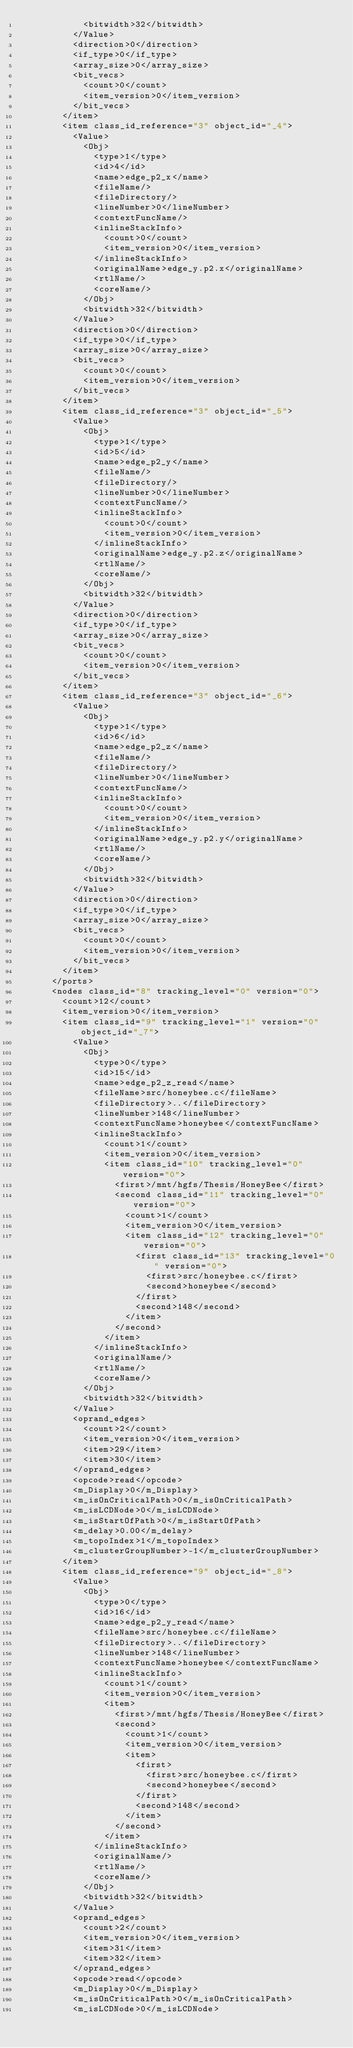Convert code to text. <code><loc_0><loc_0><loc_500><loc_500><_Ada_>            <bitwidth>32</bitwidth>
          </Value>
          <direction>0</direction>
          <if_type>0</if_type>
          <array_size>0</array_size>
          <bit_vecs>
            <count>0</count>
            <item_version>0</item_version>
          </bit_vecs>
        </item>
        <item class_id_reference="3" object_id="_4">
          <Value>
            <Obj>
              <type>1</type>
              <id>4</id>
              <name>edge_p2_x</name>
              <fileName/>
              <fileDirectory/>
              <lineNumber>0</lineNumber>
              <contextFuncName/>
              <inlineStackInfo>
                <count>0</count>
                <item_version>0</item_version>
              </inlineStackInfo>
              <originalName>edge_y.p2.x</originalName>
              <rtlName/>
              <coreName/>
            </Obj>
            <bitwidth>32</bitwidth>
          </Value>
          <direction>0</direction>
          <if_type>0</if_type>
          <array_size>0</array_size>
          <bit_vecs>
            <count>0</count>
            <item_version>0</item_version>
          </bit_vecs>
        </item>
        <item class_id_reference="3" object_id="_5">
          <Value>
            <Obj>
              <type>1</type>
              <id>5</id>
              <name>edge_p2_y</name>
              <fileName/>
              <fileDirectory/>
              <lineNumber>0</lineNumber>
              <contextFuncName/>
              <inlineStackInfo>
                <count>0</count>
                <item_version>0</item_version>
              </inlineStackInfo>
              <originalName>edge_y.p2.z</originalName>
              <rtlName/>
              <coreName/>
            </Obj>
            <bitwidth>32</bitwidth>
          </Value>
          <direction>0</direction>
          <if_type>0</if_type>
          <array_size>0</array_size>
          <bit_vecs>
            <count>0</count>
            <item_version>0</item_version>
          </bit_vecs>
        </item>
        <item class_id_reference="3" object_id="_6">
          <Value>
            <Obj>
              <type>1</type>
              <id>6</id>
              <name>edge_p2_z</name>
              <fileName/>
              <fileDirectory/>
              <lineNumber>0</lineNumber>
              <contextFuncName/>
              <inlineStackInfo>
                <count>0</count>
                <item_version>0</item_version>
              </inlineStackInfo>
              <originalName>edge_y.p2.y</originalName>
              <rtlName/>
              <coreName/>
            </Obj>
            <bitwidth>32</bitwidth>
          </Value>
          <direction>0</direction>
          <if_type>0</if_type>
          <array_size>0</array_size>
          <bit_vecs>
            <count>0</count>
            <item_version>0</item_version>
          </bit_vecs>
        </item>
      </ports>
      <nodes class_id="8" tracking_level="0" version="0">
        <count>12</count>
        <item_version>0</item_version>
        <item class_id="9" tracking_level="1" version="0" object_id="_7">
          <Value>
            <Obj>
              <type>0</type>
              <id>15</id>
              <name>edge_p2_z_read</name>
              <fileName>src/honeybee.c</fileName>
              <fileDirectory>..</fileDirectory>
              <lineNumber>148</lineNumber>
              <contextFuncName>honeybee</contextFuncName>
              <inlineStackInfo>
                <count>1</count>
                <item_version>0</item_version>
                <item class_id="10" tracking_level="0" version="0">
                  <first>/mnt/hgfs/Thesis/HoneyBee</first>
                  <second class_id="11" tracking_level="0" version="0">
                    <count>1</count>
                    <item_version>0</item_version>
                    <item class_id="12" tracking_level="0" version="0">
                      <first class_id="13" tracking_level="0" version="0">
                        <first>src/honeybee.c</first>
                        <second>honeybee</second>
                      </first>
                      <second>148</second>
                    </item>
                  </second>
                </item>
              </inlineStackInfo>
              <originalName/>
              <rtlName/>
              <coreName/>
            </Obj>
            <bitwidth>32</bitwidth>
          </Value>
          <oprand_edges>
            <count>2</count>
            <item_version>0</item_version>
            <item>29</item>
            <item>30</item>
          </oprand_edges>
          <opcode>read</opcode>
          <m_Display>0</m_Display>
          <m_isOnCriticalPath>0</m_isOnCriticalPath>
          <m_isLCDNode>0</m_isLCDNode>
          <m_isStartOfPath>0</m_isStartOfPath>
          <m_delay>0.00</m_delay>
          <m_topoIndex>1</m_topoIndex>
          <m_clusterGroupNumber>-1</m_clusterGroupNumber>
        </item>
        <item class_id_reference="9" object_id="_8">
          <Value>
            <Obj>
              <type>0</type>
              <id>16</id>
              <name>edge_p2_y_read</name>
              <fileName>src/honeybee.c</fileName>
              <fileDirectory>..</fileDirectory>
              <lineNumber>148</lineNumber>
              <contextFuncName>honeybee</contextFuncName>
              <inlineStackInfo>
                <count>1</count>
                <item_version>0</item_version>
                <item>
                  <first>/mnt/hgfs/Thesis/HoneyBee</first>
                  <second>
                    <count>1</count>
                    <item_version>0</item_version>
                    <item>
                      <first>
                        <first>src/honeybee.c</first>
                        <second>honeybee</second>
                      </first>
                      <second>148</second>
                    </item>
                  </second>
                </item>
              </inlineStackInfo>
              <originalName/>
              <rtlName/>
              <coreName/>
            </Obj>
            <bitwidth>32</bitwidth>
          </Value>
          <oprand_edges>
            <count>2</count>
            <item_version>0</item_version>
            <item>31</item>
            <item>32</item>
          </oprand_edges>
          <opcode>read</opcode>
          <m_Display>0</m_Display>
          <m_isOnCriticalPath>0</m_isOnCriticalPath>
          <m_isLCDNode>0</m_isLCDNode></code> 